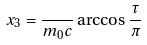Convert formula to latex. <formula><loc_0><loc_0><loc_500><loc_500>x _ { 3 } = \frac { } { m _ { 0 } c } \arccos { \frac { \tau } { \pi } }</formula> 